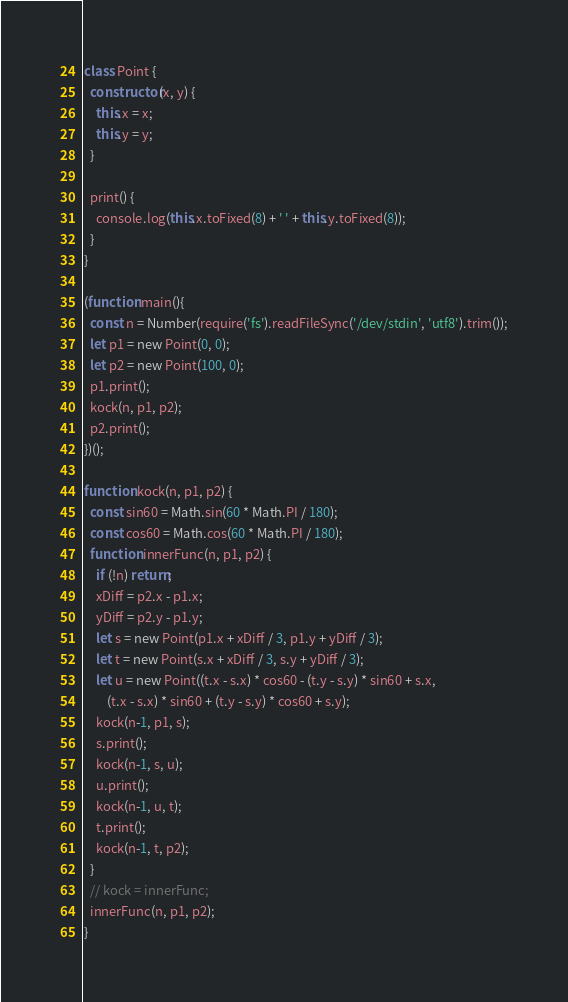Convert code to text. <code><loc_0><loc_0><loc_500><loc_500><_JavaScript_>class Point {
  constructor(x, y) {
    this.x = x;
    this.y = y;
  }

  print() {
    console.log(this.x.toFixed(8) + ' ' + this.y.toFixed(8));
  }
}

(function main(){
  const n = Number(require('fs').readFileSync('/dev/stdin', 'utf8').trim());
  let p1 = new Point(0, 0);
  let p2 = new Point(100, 0);
  p1.print();
  kock(n, p1, p2);
  p2.print();
})();

function kock(n, p1, p2) {
  const sin60 = Math.sin(60 * Math.PI / 180);
  const cos60 = Math.cos(60 * Math.PI / 180);
  function innerFunc(n, p1, p2) {
    if (!n) return;
    xDiff = p2.x - p1.x;
    yDiff = p2.y - p1.y;
    let s = new Point(p1.x + xDiff / 3, p1.y + yDiff / 3);
    let t = new Point(s.x + xDiff / 3, s.y + yDiff / 3);
    let u = new Point((t.x - s.x) * cos60 - (t.y - s.y) * sin60 + s.x,
        (t.x - s.x) * sin60 + (t.y - s.y) * cos60 + s.y);
    kock(n-1, p1, s);
    s.print();
    kock(n-1, s, u);
    u.print();
    kock(n-1, u, t);
    t.print();
    kock(n-1, t, p2);
  }
  // kock = innerFunc;
  innerFunc(n, p1, p2);
}

</code> 